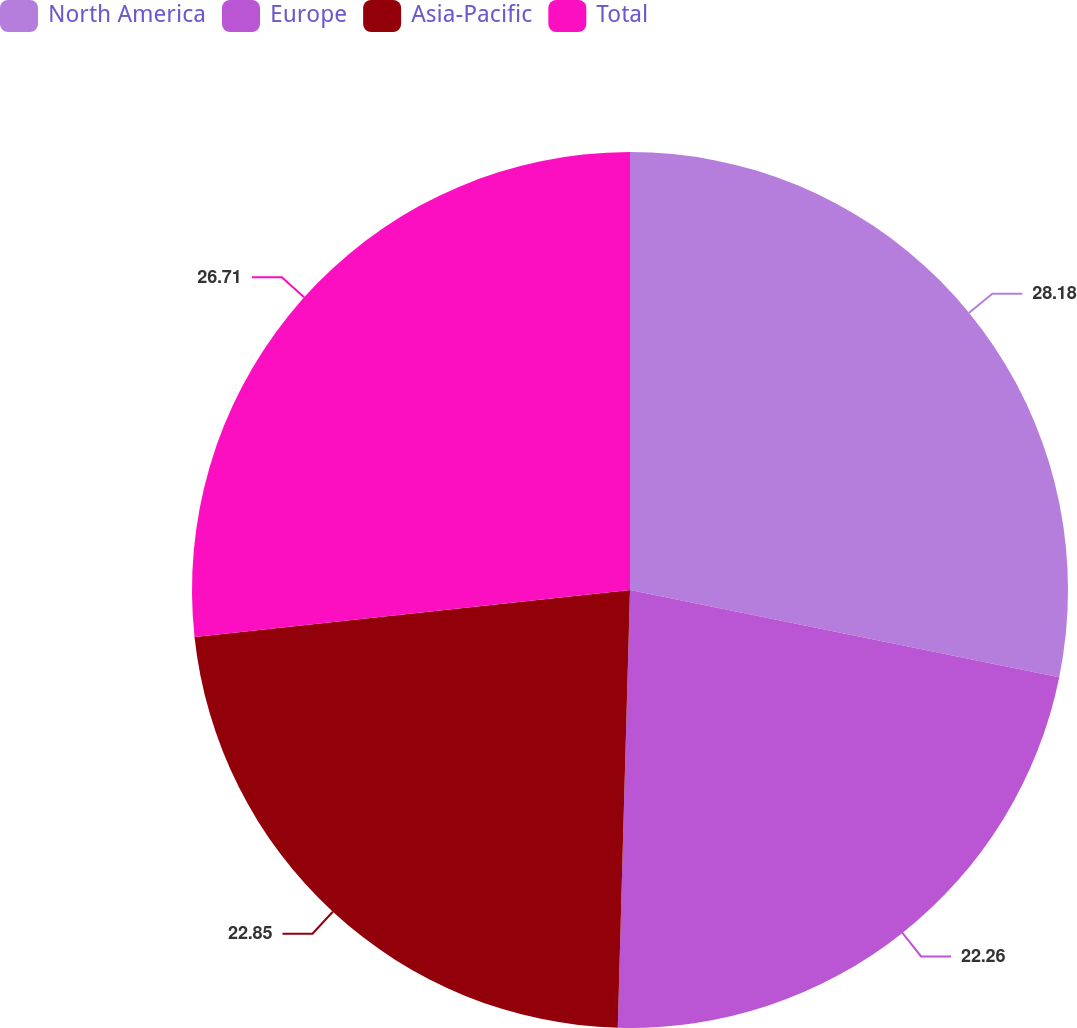Convert chart. <chart><loc_0><loc_0><loc_500><loc_500><pie_chart><fcel>North America<fcel>Europe<fcel>Asia-Pacific<fcel>Total<nl><fcel>28.19%<fcel>22.26%<fcel>22.85%<fcel>26.71%<nl></chart> 